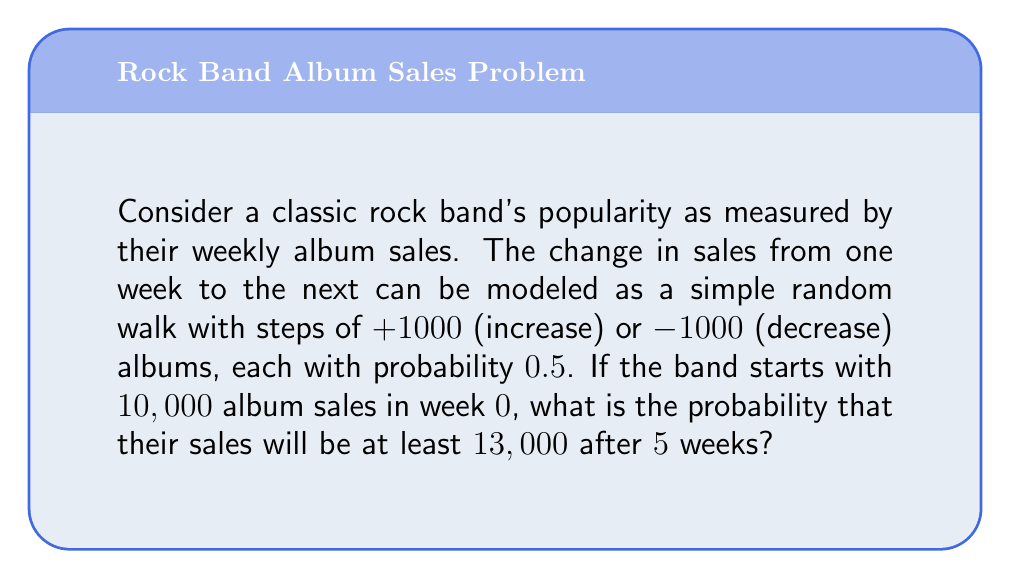Can you answer this question? Let's approach this step-by-step:

1) This is a simple symmetric random walk. Let $S_n$ be the number of album sales after n weeks.

2) We start with $S_0 = 10,000$.

3) To reach at least 13,000 sales after 5 weeks, the band needs a net increase of at least 3,000 albums.

4) Each step is either +1000 or -1000. So to increase by 3000, we need at least 3 more up steps than down steps.

5) Let X be the number of up steps. Then 5-X is the number of down steps. We need:

   $1000X - 1000(5-X) \geq 3000$
   $2X - 5 \geq 3$
   $X \geq 4$

6) So we need 4 or 5 up steps out of 5 total steps.

7) This follows a binomial distribution with n=5 and p=0.5.

8) The probability is:

   $P(X \geq 4) = P(X=4) + P(X=5)$

   $= \binom{5}{4}(0.5)^4(0.5)^1 + \binom{5}{5}(0.5)^5$

   $= 5(0.5)^5 + (0.5)^5$

   $= 5(0.03125) + 0.03125$

   $= 0.15625 + 0.03125$

   $= 0.1875$
Answer: 0.1875 